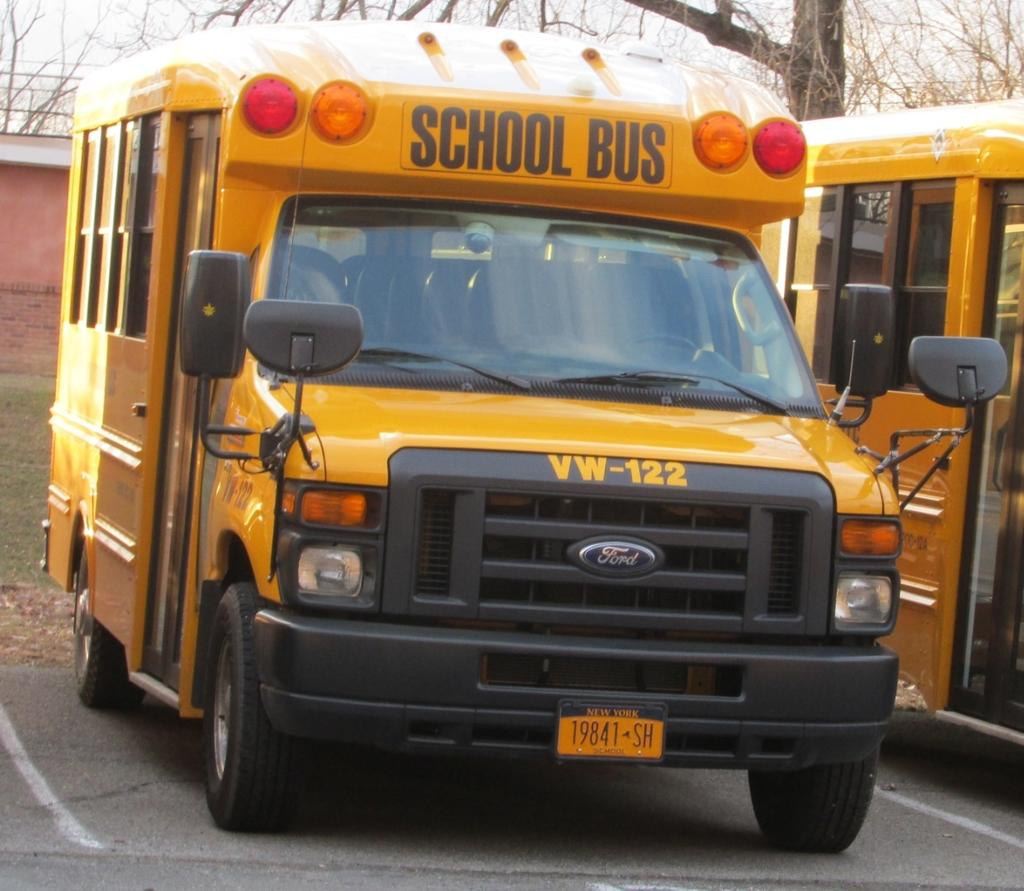<image>
Present a compact description of the photo's key features. School Bus vehicle that says VW-122 and has a New York License Plate: 19841 SH School. 